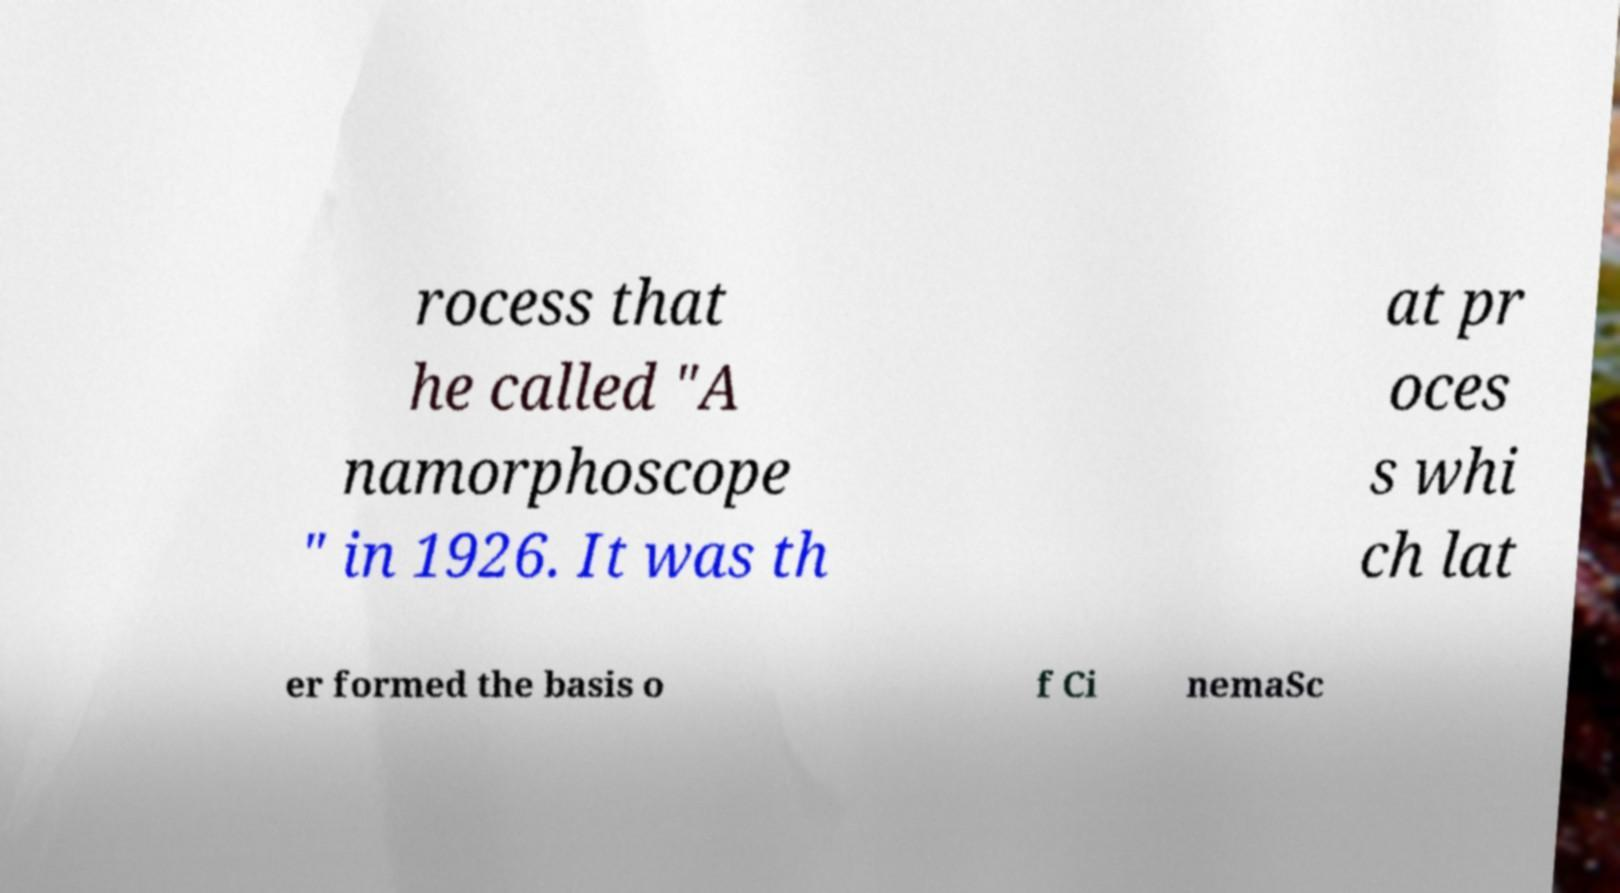Could you extract and type out the text from this image? rocess that he called "A namorphoscope " in 1926. It was th at pr oces s whi ch lat er formed the basis o f Ci nemaSc 